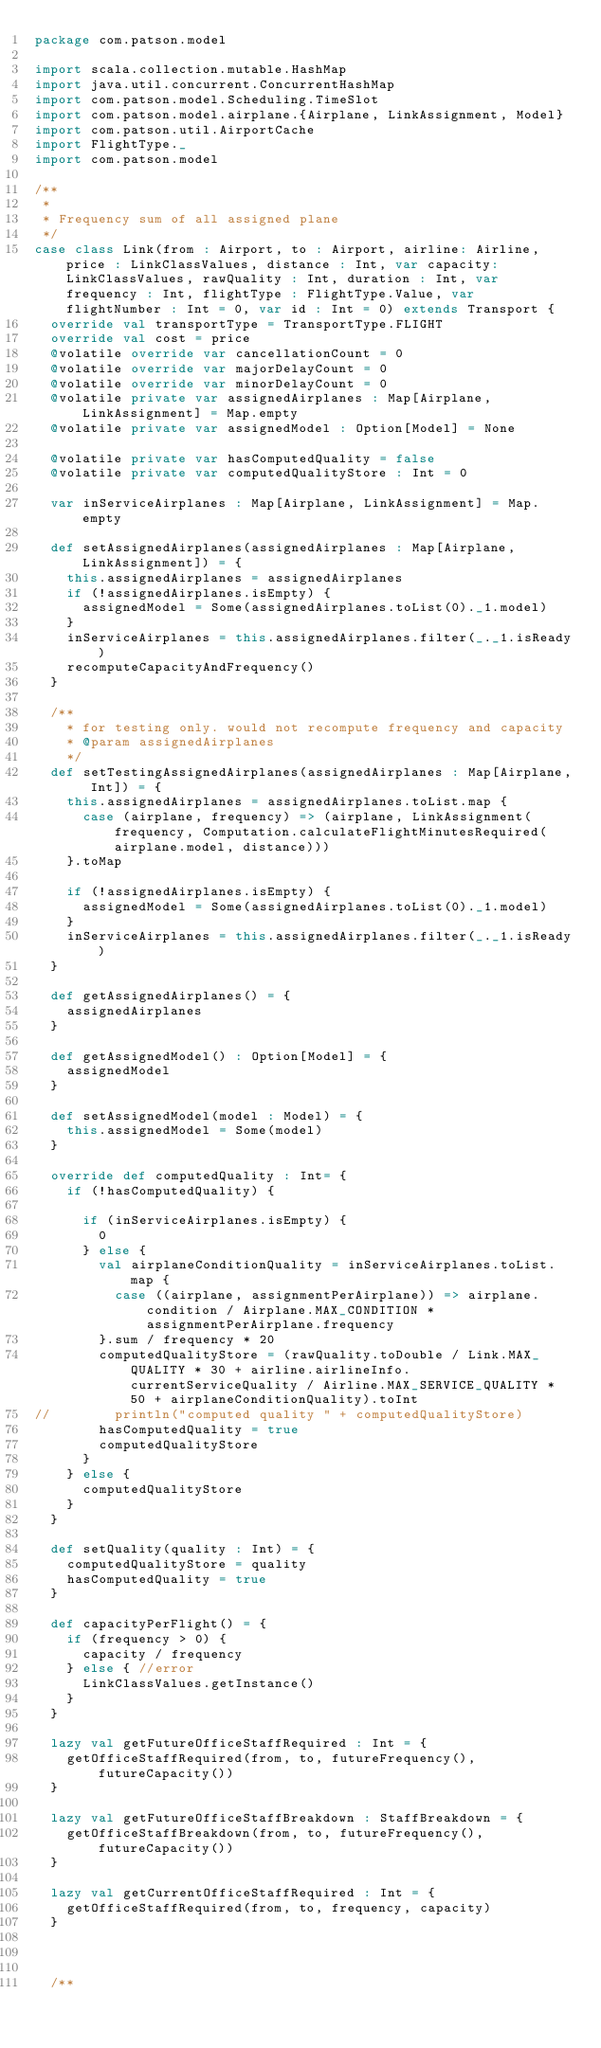<code> <loc_0><loc_0><loc_500><loc_500><_Scala_>package com.patson.model

import scala.collection.mutable.HashMap
import java.util.concurrent.ConcurrentHashMap
import com.patson.model.Scheduling.TimeSlot
import com.patson.model.airplane.{Airplane, LinkAssignment, Model}
import com.patson.util.AirportCache
import FlightType._
import com.patson.model

/**
 * 
 * Frequency sum of all assigned plane
 */
case class Link(from : Airport, to : Airport, airline: Airline, price : LinkClassValues, distance : Int, var capacity: LinkClassValues, rawQuality : Int, duration : Int, var frequency : Int, flightType : FlightType.Value, var flightNumber : Int = 0, var id : Int = 0) extends Transport {
  override val transportType = TransportType.FLIGHT
  override val cost = price
  @volatile override var cancellationCount = 0
  @volatile override var majorDelayCount = 0
  @volatile override var minorDelayCount = 0
  @volatile private var assignedAirplanes : Map[Airplane, LinkAssignment] = Map.empty
  @volatile private var assignedModel : Option[Model] = None
  
  @volatile private var hasComputedQuality = false
  @volatile private var computedQualityStore : Int = 0

  var inServiceAirplanes : Map[Airplane, LinkAssignment] = Map.empty

  def setAssignedAirplanes(assignedAirplanes : Map[Airplane, LinkAssignment]) = {
    this.assignedAirplanes = assignedAirplanes
    if (!assignedAirplanes.isEmpty) {
      assignedModel = Some(assignedAirplanes.toList(0)._1.model)
    }
    inServiceAirplanes = this.assignedAirplanes.filter(_._1.isReady)
    recomputeCapacityAndFrequency()
  }

  /**
    * for testing only. would not recompute frequency and capacity
    * @param assignedAirplanes
    */
  def setTestingAssignedAirplanes(assignedAirplanes : Map[Airplane, Int]) = {
    this.assignedAirplanes = assignedAirplanes.toList.map {
      case (airplane, frequency) => (airplane, LinkAssignment(frequency, Computation.calculateFlightMinutesRequired(airplane.model, distance)))
    }.toMap

    if (!assignedAirplanes.isEmpty) {
      assignedModel = Some(assignedAirplanes.toList(0)._1.model)
    }
    inServiceAirplanes = this.assignedAirplanes.filter(_._1.isReady)
  }
  
  def getAssignedAirplanes() = {
    assignedAirplanes
  }
  
  def getAssignedModel() : Option[Model] = {
    assignedModel
  }

  def setAssignedModel(model : Model) = {
    this.assignedModel = Some(model)
  }

  override def computedQuality : Int= {
    if (!hasComputedQuality) {

      if (inServiceAirplanes.isEmpty) {
        0
      } else {
        val airplaneConditionQuality = inServiceAirplanes.toList.map {
          case ((airplane, assignmentPerAirplane)) => airplane.condition / Airplane.MAX_CONDITION * assignmentPerAirplane.frequency
        }.sum / frequency * 20
        computedQualityStore = (rawQuality.toDouble / Link.MAX_QUALITY * 30 + airline.airlineInfo.currentServiceQuality / Airline.MAX_SERVICE_QUALITY * 50 + airplaneConditionQuality).toInt
//        println("computed quality " + computedQualityStore)
        hasComputedQuality = true
        computedQualityStore
      }
    } else {
      computedQualityStore
    }
  }

  def setQuality(quality : Int) = {
    computedQualityStore = quality
    hasComputedQuality = true
  }

  def capacityPerFlight() = {
    if (frequency > 0) {
      capacity / frequency
    } else { //error 
      LinkClassValues.getInstance()
    }
  }

  lazy val getFutureOfficeStaffRequired : Int = {
    getOfficeStaffRequired(from, to, futureFrequency(), futureCapacity())
  }

  lazy val getFutureOfficeStaffBreakdown : StaffBreakdown = {
    getOfficeStaffBreakdown(from, to, futureFrequency(), futureCapacity())
  }

  lazy val getCurrentOfficeStaffRequired : Int = {
    getOfficeStaffRequired(from, to, frequency, capacity)
  }



  /**</code> 